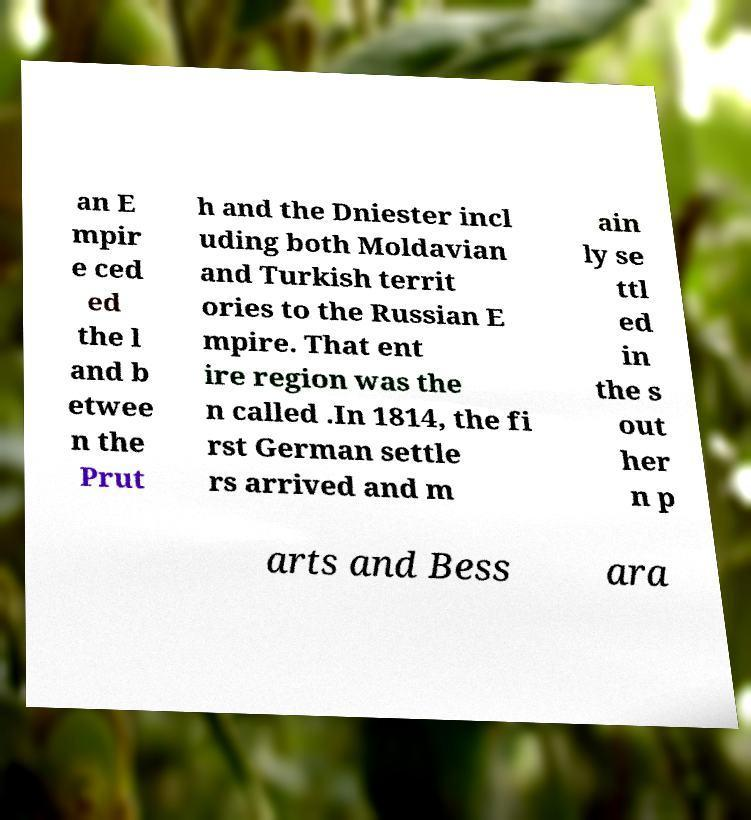Could you assist in decoding the text presented in this image and type it out clearly? an E mpir e ced ed the l and b etwee n the Prut h and the Dniester incl uding both Moldavian and Turkish territ ories to the Russian E mpire. That ent ire region was the n called .In 1814, the fi rst German settle rs arrived and m ain ly se ttl ed in the s out her n p arts and Bess ara 